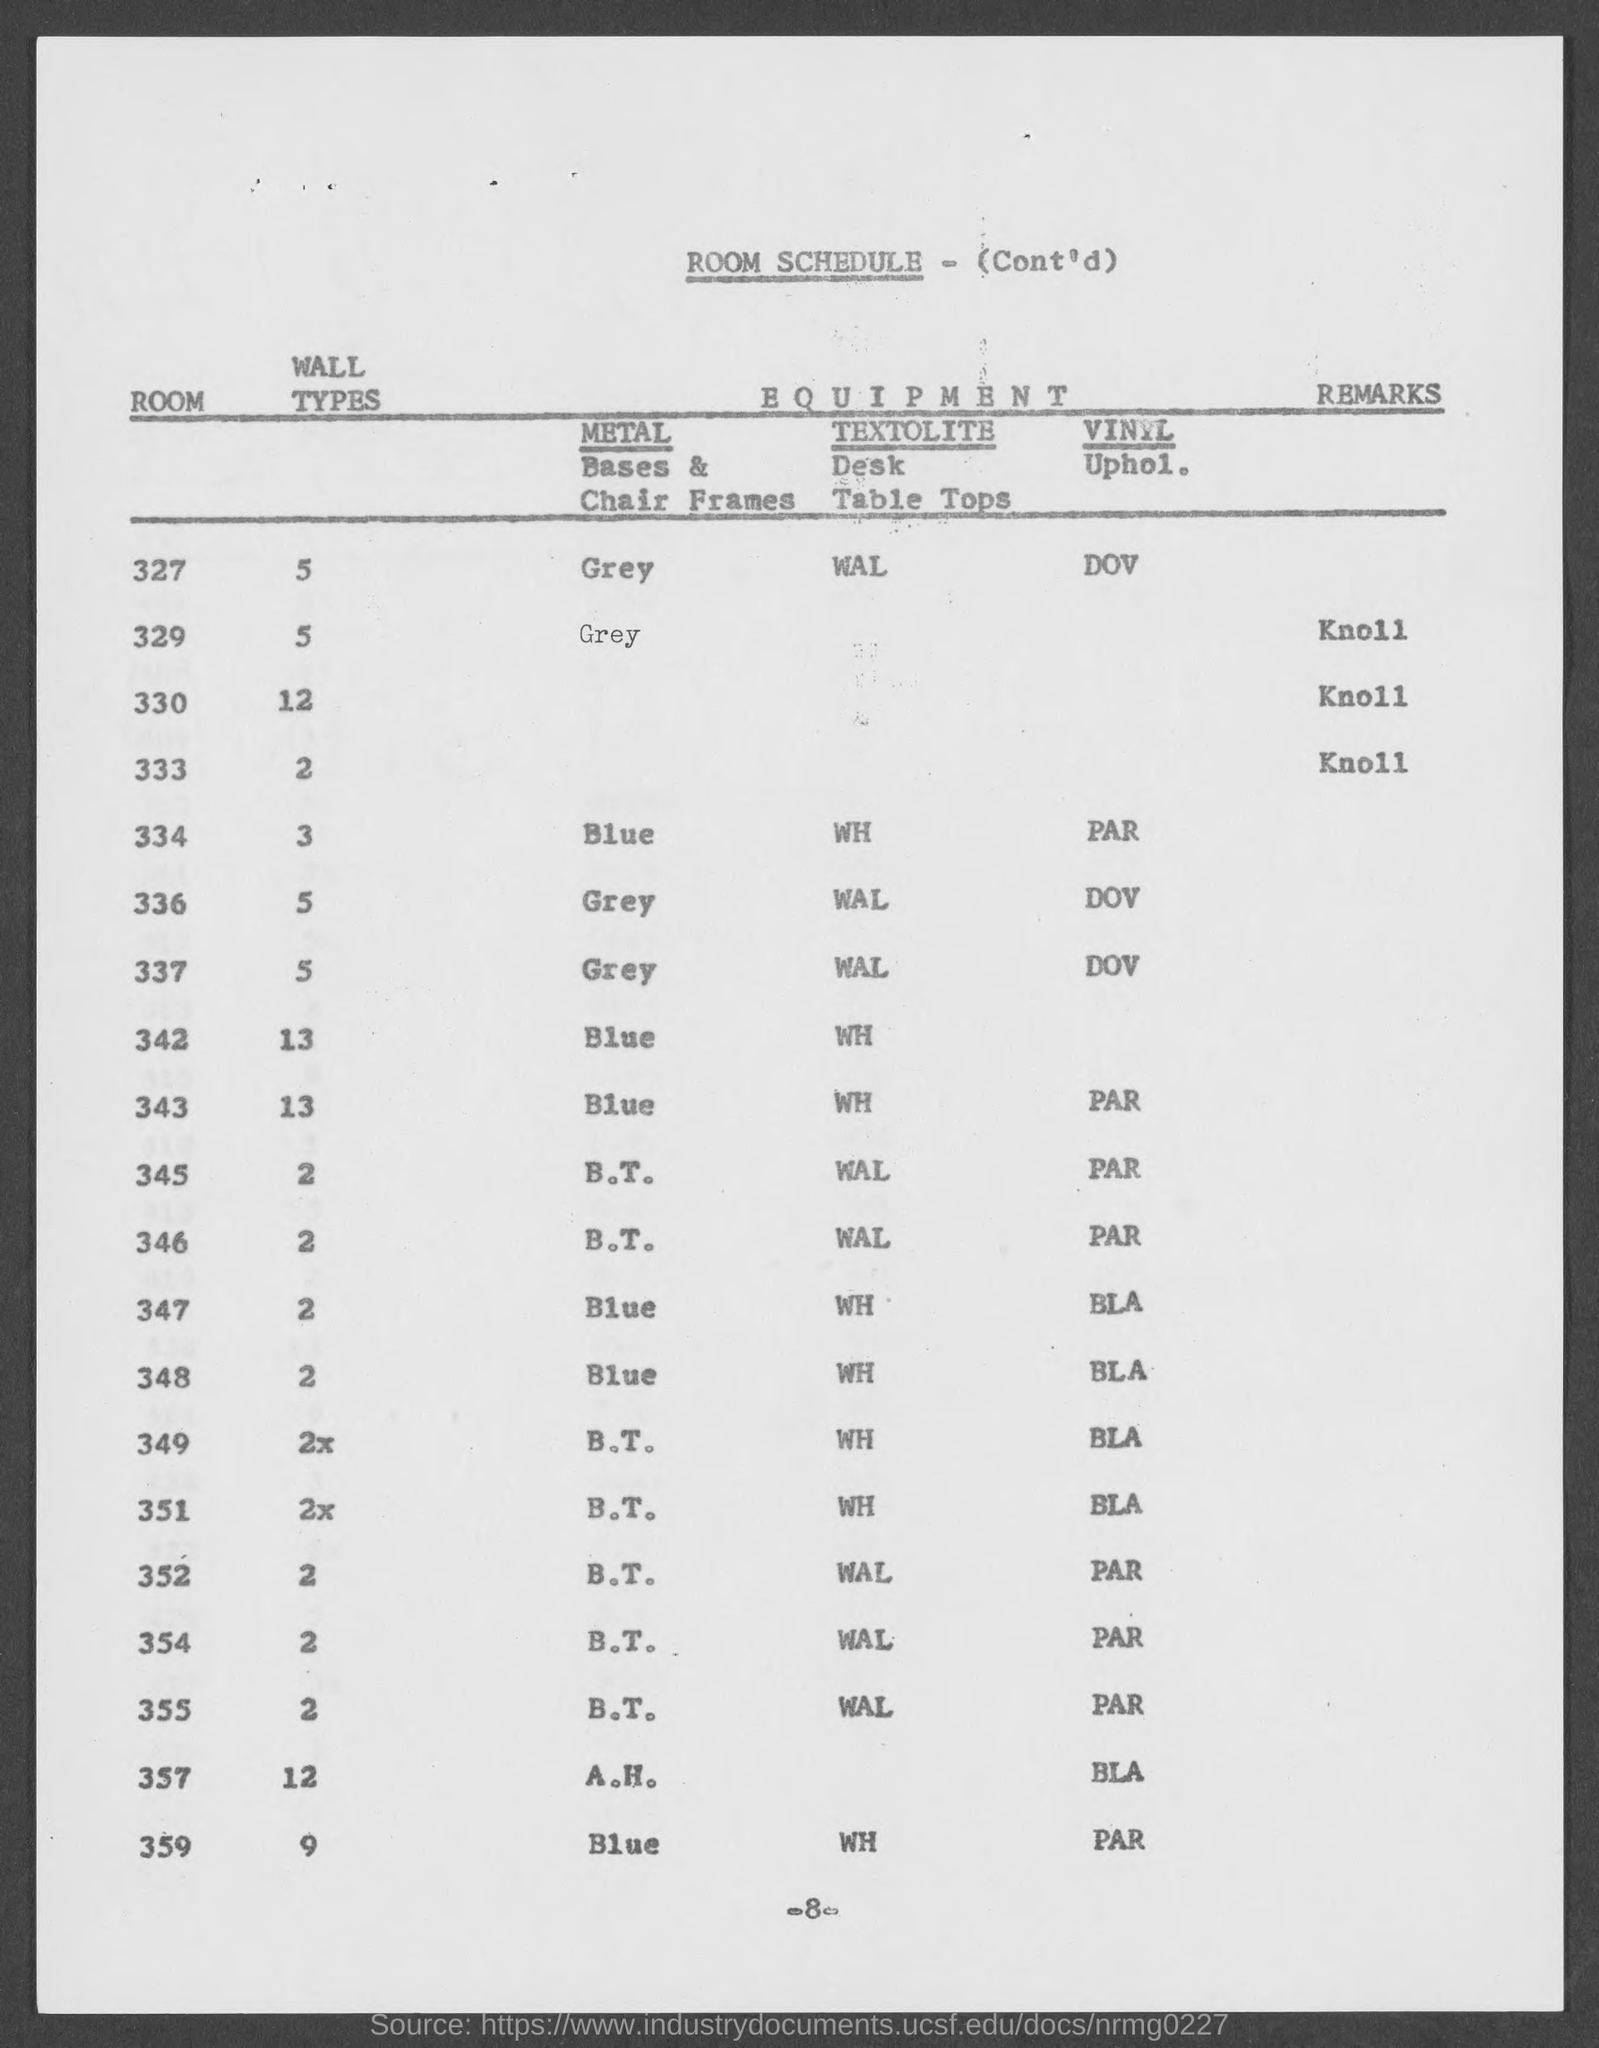What is the page no mentioned in this document?
Keep it short and to the point. -8-. What is the wall type used for the Room 334 as per the room schedule?
Provide a succinct answer. 3. What is the wall type used for the Room 327 as per the room schedule?
Offer a very short reply. 5. Which Metal Bases & Chair Frames are used for the Room 334?
Your answer should be compact. Blue. What is the VINYL Uphol. used for Room 337 as per the room schedule?
Provide a succinct answer. DOV. What is the VINYL Uphol. used for Room 343 as per the room schedule?
Provide a succinct answer. PAR. What is the wall type used for the Room 349 as per the room schedule?
Offer a terse response. 2x. 